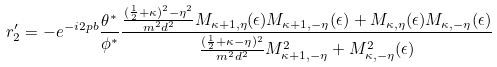<formula> <loc_0><loc_0><loc_500><loc_500>r ^ { \prime } _ { 2 } = - e ^ { - i 2 p b } \frac { \theta ^ { * } } { \phi ^ { * } } \frac { \frac { ( \frac { 1 } { 2 } + \kappa ) ^ { 2 } - \eta ^ { 2 } } { m ^ { 2 } d ^ { 2 } } M _ { \kappa + 1 , \eta } ( \epsilon ) M _ { \kappa + 1 , - \eta } ( \epsilon ) + M _ { \kappa , \eta } ( \epsilon ) M _ { \kappa , - \eta } ( \epsilon ) } { \frac { ( \frac { 1 } { 2 } + \kappa - \eta ) ^ { 2 } } { m ^ { 2 } d ^ { 2 } } M ^ { 2 } _ { \kappa + 1 , - \eta } + M ^ { 2 } _ { \kappa , - \eta } ( \epsilon ) }</formula> 